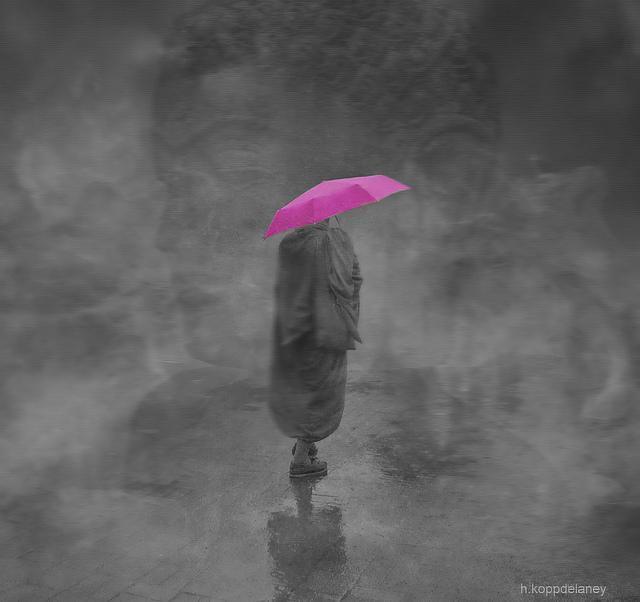How many images are superimposed in the picture?
Give a very brief answer. 1. 